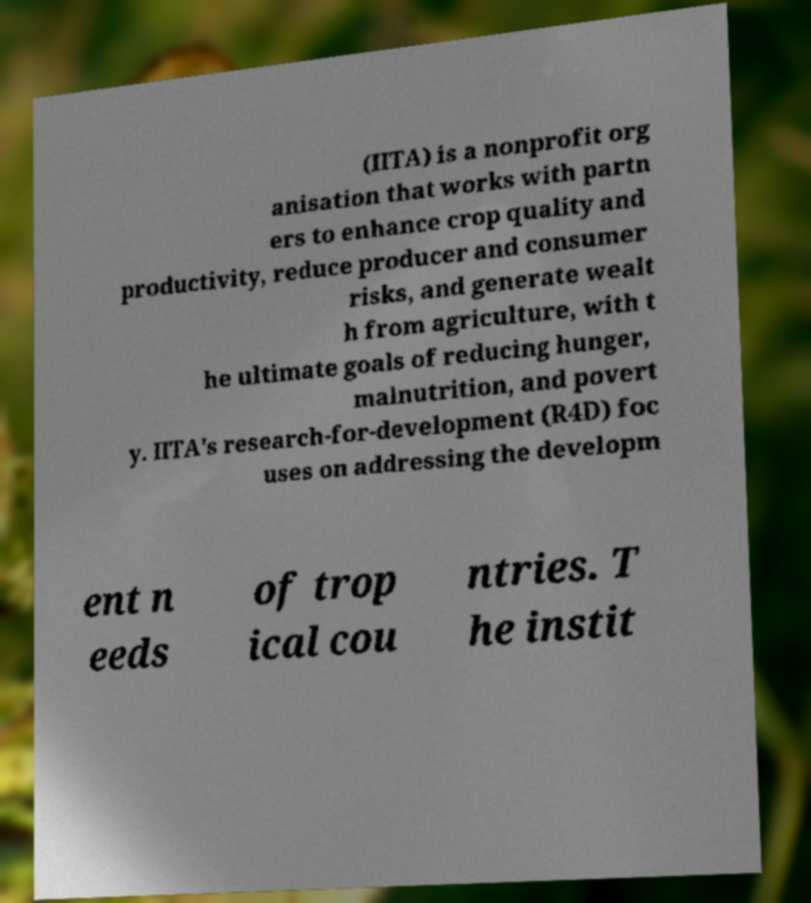There's text embedded in this image that I need extracted. Can you transcribe it verbatim? (IITA) is a nonprofit org anisation that works with partn ers to enhance crop quality and productivity, reduce producer and consumer risks, and generate wealt h from agriculture, with t he ultimate goals of reducing hunger, malnutrition, and povert y. IITA's research-for-development (R4D) foc uses on addressing the developm ent n eeds of trop ical cou ntries. T he instit 